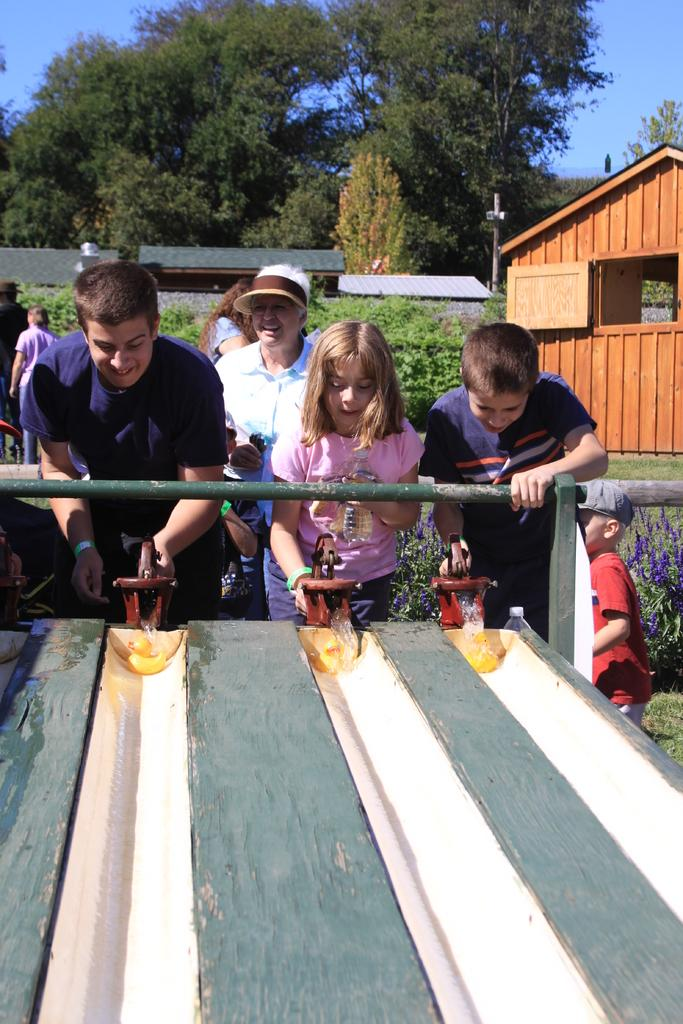What are the people in the image doing? The people in the image are standing and playing a game. What can be seen in the background of the image? There is a shed and trees visible in the background of the image. What is visible in the sky in the image? The sky is visible in the image. What type of pin is being used to hold the pot in the image? There is no pin or pot present in the image. How much credit is being given to the players in the image? The image does not show any credit being given to the players; it only depicts them playing a game. 